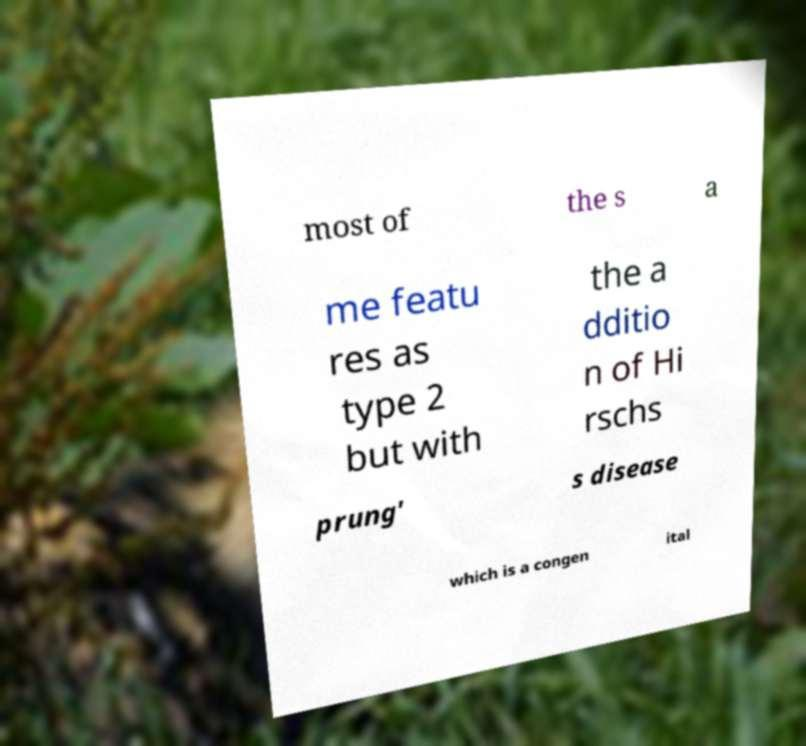Could you assist in decoding the text presented in this image and type it out clearly? most of the s a me featu res as type 2 but with the a dditio n of Hi rschs prung' s disease which is a congen ital 